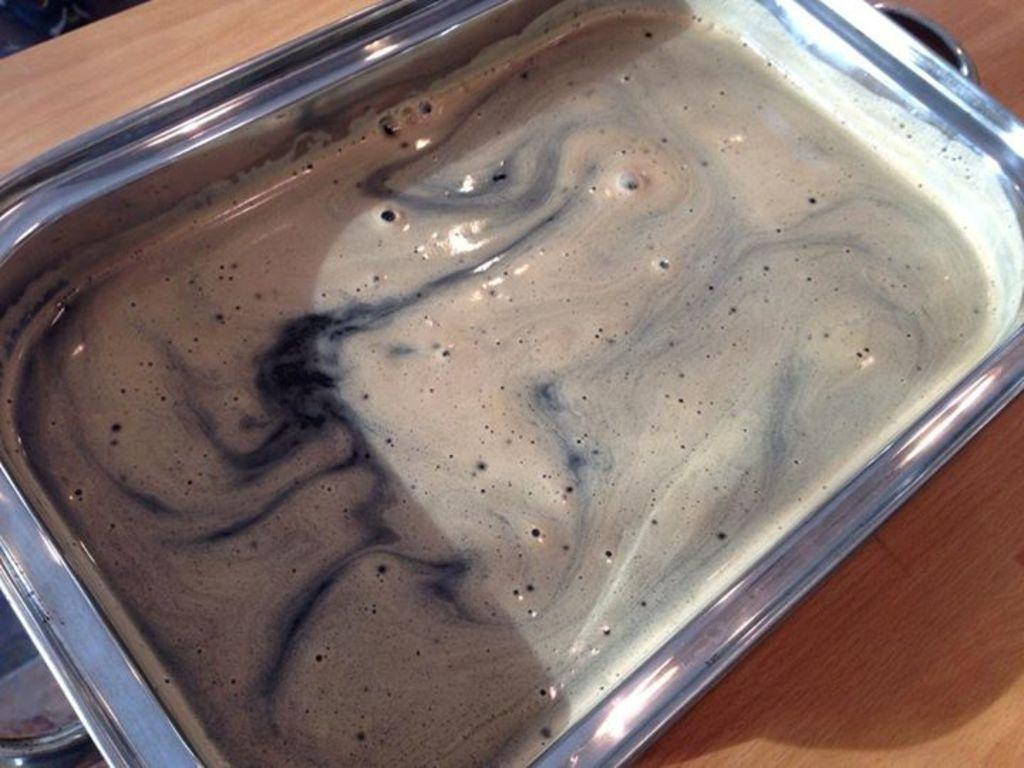What object is present in the image that can hold items? There is a tray in the image that can hold items. What is contained within the tray in the image? The tray contains a liquid. Where is the tray located in the image? The tray is placed on a table. What type of news is being reported on the dress in the image? There is no dress present in the image, and therefore no news being reported on it. 